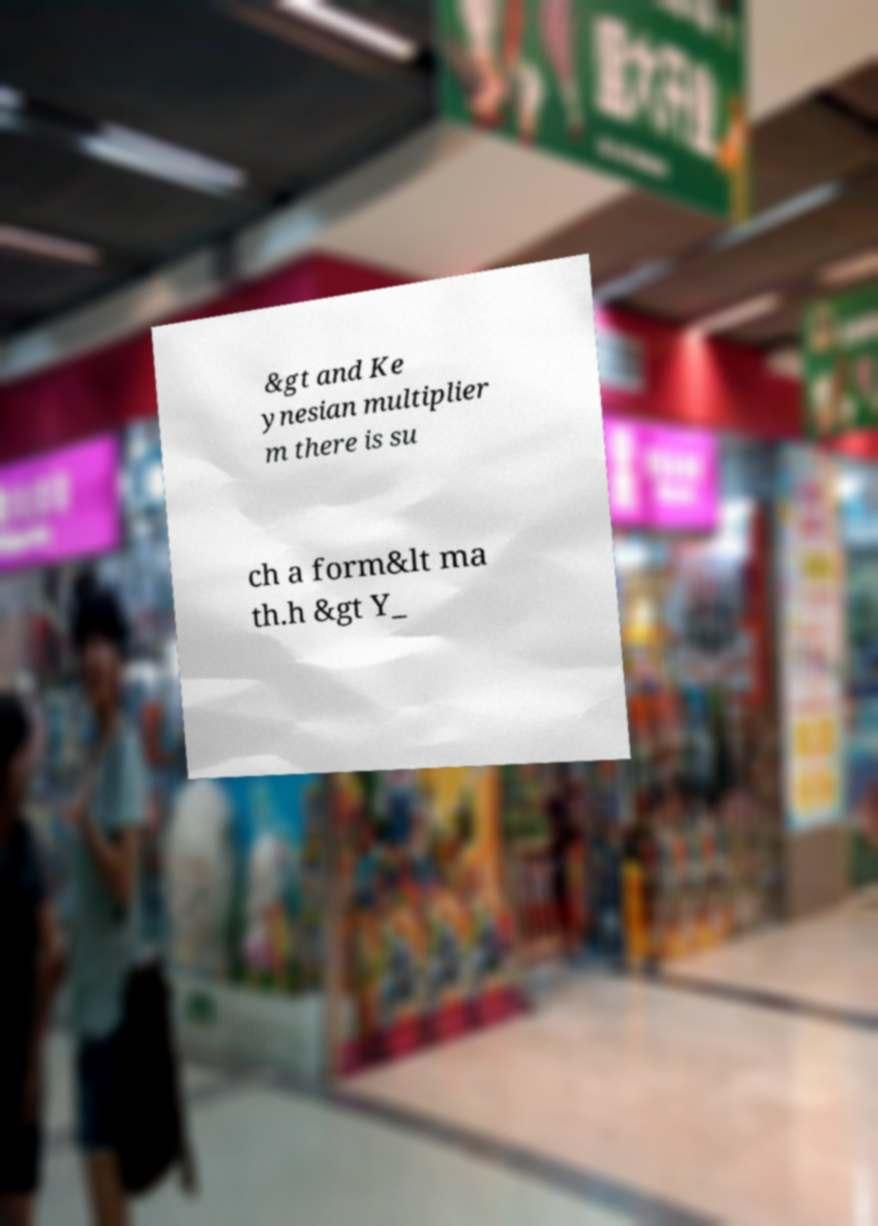Could you assist in decoding the text presented in this image and type it out clearly? &gt and Ke ynesian multiplier m there is su ch a form&lt ma th.h &gt Y_ 